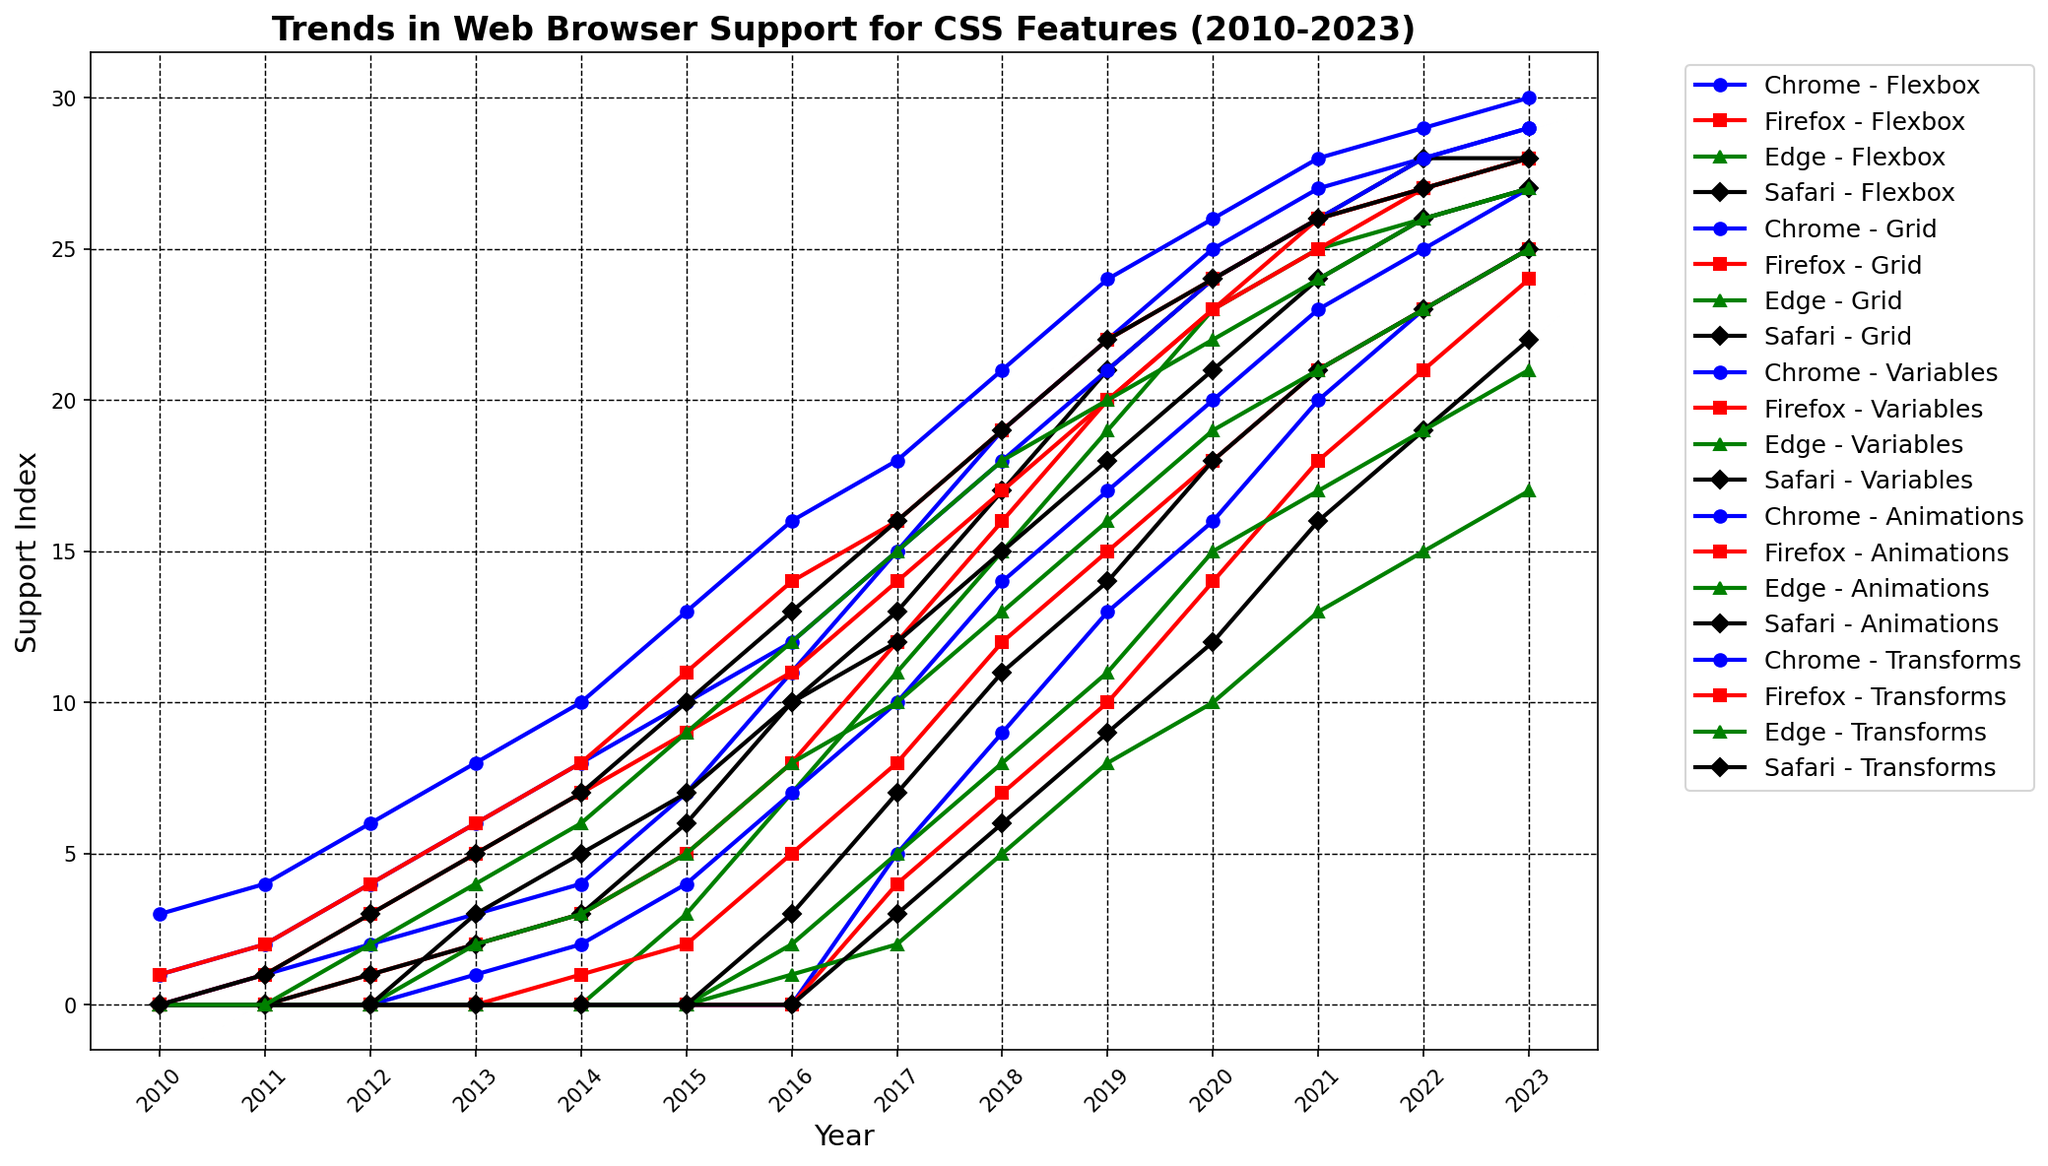What trend can be observed for the support of CSS Grid in Chrome from 2016 to 2023? The figure shows that CSS Grid support in Chrome started from 0 in 2016, climbed to 5 in 2017, 9 in 2018, 13 in 2019, 16 in 2020, 20 in 2021, 23 in 2022, and reached 25 in 2023.
Answer: Continuous increase Which CSS feature saw the earliest support in any browser? By reviewing the early years (2010), CSS Transforms were supported by Chrome (3) and Firefox (1). Other features had zero support in all browsers that year.
Answer: CSS Transforms In what year did Edge start to support CSS Grid, and what was its index value? Checking the data for Edge, CSS Grid support began in 2016 with a support index of 1.
Answer: 2016, 1 Between CSS Variables in Safari and Firefox, which browser had higher support by 2023? The figure shows that by 2023, CSS Variables had a support index of 25 in Safari and 21 in Firefox.
Answer: Safari From 2010 to 2013, how did the support of CSS Flexbox in Safari evolve? Initially, there was no support in 2010. In 2011, the support was 0, in 2012 it increased to 1, in 2013 it rose to 2.
Answer: Slow increase What is the difference in the support index for CSS Animations between 2020 and 2023 for Firefox? The figure shows that in 2020, the support index was 23, and by 2023, it was 28. The difference is 28 - 23.
Answer: 5 Which browser showed the most consistent increase in support for CSS Transforms from 2010 to 2023? By inspecting each browser trendline for CSS Transforms, Chrome displays the most steady and consistent upward increase. It jumped from 3 in 2010 to 30 in 2023.
Answer: Chrome By 2015, which browser had the highest support for CSS Flexbox, and what was the value? In 2015, Chrome had the highest support for CSS Flexbox with a value of 7.
Answer: Chrome, 7 How did the support for CSS Variables change in Edge from 2012 to 2016? From 2012 to 2016, Edge initially had no support (0) until 2015. In 2016, it started supporting with an index of 2.
Answer: Increase from 0 to 2 Comparing all browsers in 2023, which CSS feature had the lowest overall support, and what was its value? Looking at the 2023 values across all features and browsers, CSS Grid in Edge had the lowest support with a value of 17.
Answer: CSS Grid, 17 